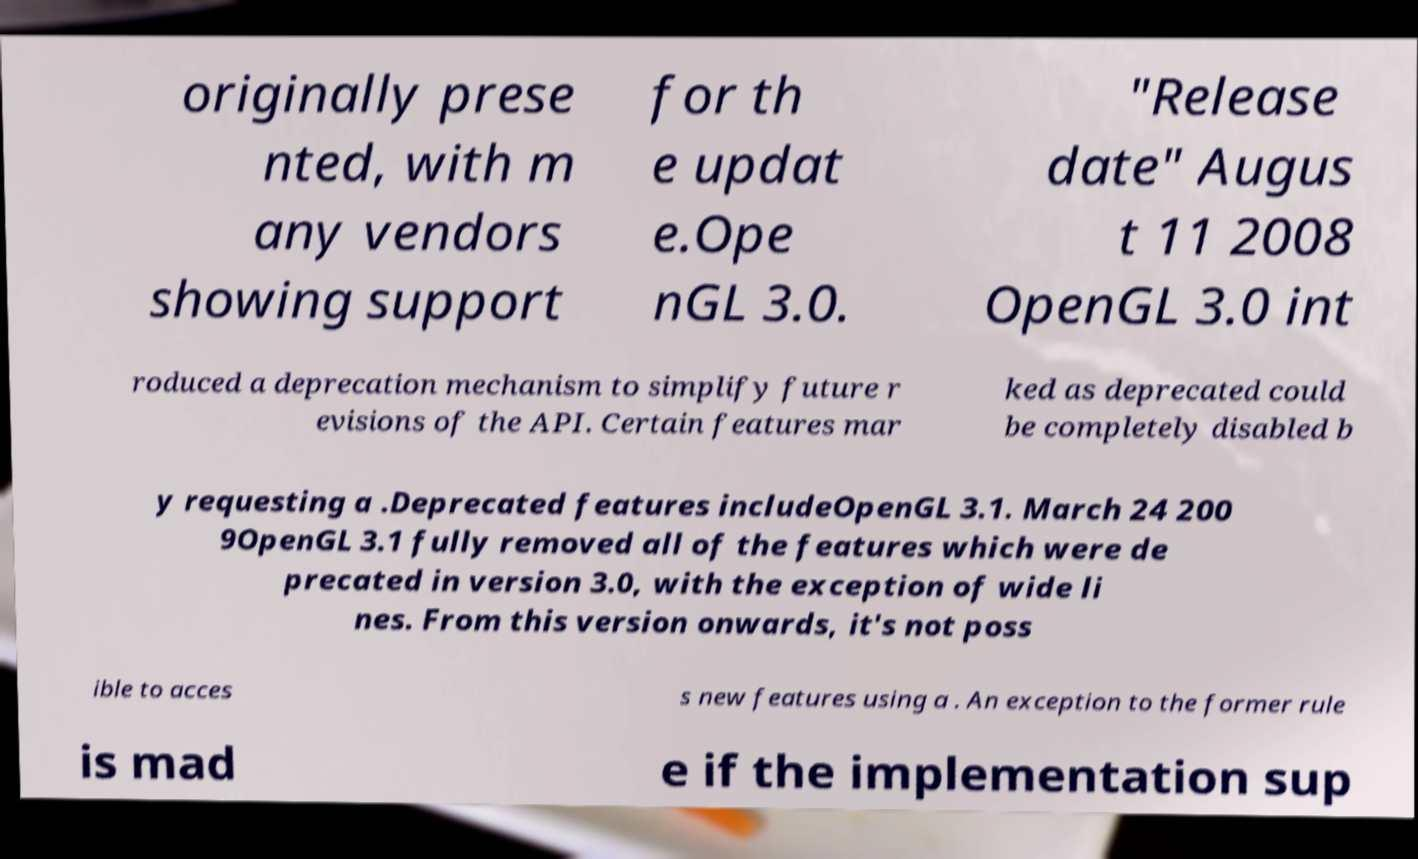What messages or text are displayed in this image? I need them in a readable, typed format. originally prese nted, with m any vendors showing support for th e updat e.Ope nGL 3.0. "Release date" Augus t 11 2008 OpenGL 3.0 int roduced a deprecation mechanism to simplify future r evisions of the API. Certain features mar ked as deprecated could be completely disabled b y requesting a .Deprecated features includeOpenGL 3.1. March 24 200 9OpenGL 3.1 fully removed all of the features which were de precated in version 3.0, with the exception of wide li nes. From this version onwards, it's not poss ible to acces s new features using a . An exception to the former rule is mad e if the implementation sup 